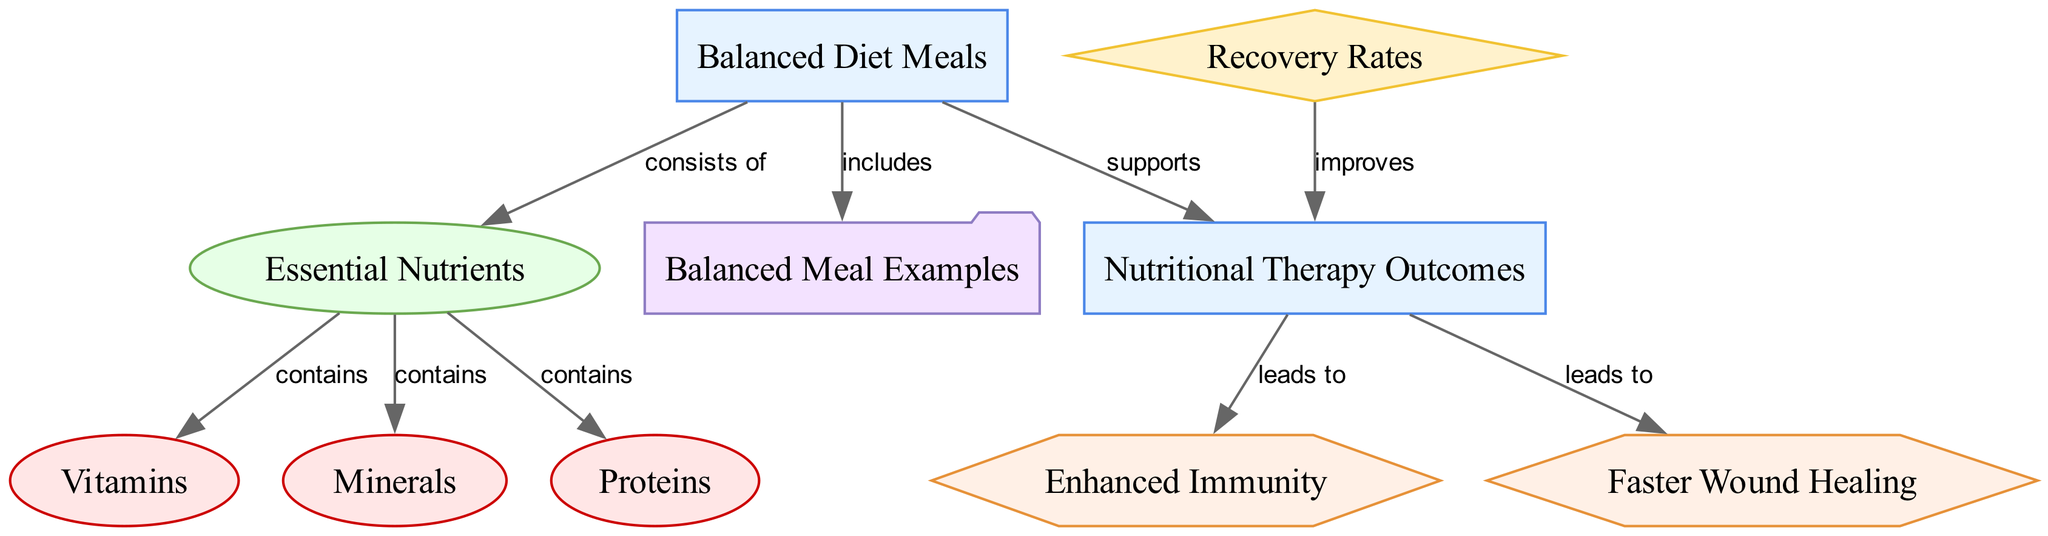What is the main category of meals discussed in the diagram? The diagram highlights 'Balanced Diet Meals' as the main category, denoted at the top of the diagram.
Answer: Balanced Diet Meals How many essential nutrients are listed in the diagram? The diagram connects 'nutrients' to three components: 'vitamins', 'minerals', and 'proteins', indicating the number of essential nutrients as three.
Answer: Three What benefits are associated with nutritional therapy as per the diagram? The diagram shows 'Nutritional Therapy Outcomes' leading to two benefits: 'Enhanced Immunity' and 'Faster Wound Healing', implying these two benefits are associated with nutritional therapy.
Answer: Enhanced Immunity, Faster Wound Healing What does the balanced diet support? According to the diagram, 'Balanced Diet Meals' supports 'Nutritional Therapy', establishing a direct relationship between them.
Answer: Nutritional Therapy Which component is specifically related to 'proteins'? The diagram indicates 'proteins' as one of the components that 'nutrients' contains, establishing 'proteins' as directly related to the concept of nutrients.
Answer: Proteins How do balanced diet meals affect recovery rates? The diagram shows that 'balanced diet meals' directly improves 'recovery rates' through support for 'nutritional therapy', indicating a positive effect on recovery rates.
Answer: Improves What type of relationships are present in the diagram? The diagram presents various relationships including 'includes', 'contains', and 'leads to', which are denoted as edge labels between nodes, explaining the connections between categories, metrics, and benefits.
Answer: Includes, Contains, Leads to Which example category is provided in the diagram? The diagram categorizes examples under 'Balanced Meal Examples', indicating this specific category for illustrations or references of balanced meals.
Answer: Balanced Meal Examples How does nutritional therapy influence immune response? The diagram links 'Nutritional Therapy' to 'Enhanced Immunity', indicating that nutritional therapy leads to improvements in the immune response specifically.
Answer: Enhanced Immunity 